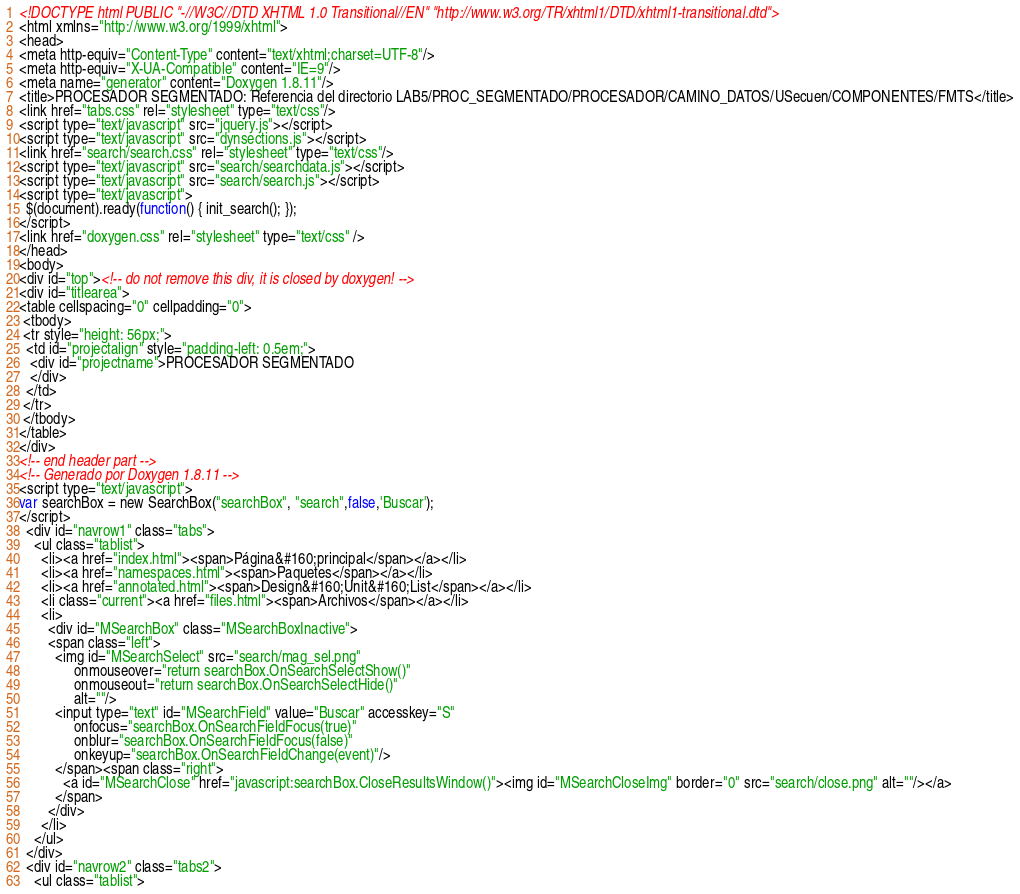<code> <loc_0><loc_0><loc_500><loc_500><_HTML_><!DOCTYPE html PUBLIC "-//W3C//DTD XHTML 1.0 Transitional//EN" "http://www.w3.org/TR/xhtml1/DTD/xhtml1-transitional.dtd">
<html xmlns="http://www.w3.org/1999/xhtml">
<head>
<meta http-equiv="Content-Type" content="text/xhtml;charset=UTF-8"/>
<meta http-equiv="X-UA-Compatible" content="IE=9"/>
<meta name="generator" content="Doxygen 1.8.11"/>
<title>PROCESADOR SEGMENTADO: Referencia del directorio LAB5/PROC_SEGMENTADO/PROCESADOR/CAMINO_DATOS/USecuen/COMPONENTES/FMTS</title>
<link href="tabs.css" rel="stylesheet" type="text/css"/>
<script type="text/javascript" src="jquery.js"></script>
<script type="text/javascript" src="dynsections.js"></script>
<link href="search/search.css" rel="stylesheet" type="text/css"/>
<script type="text/javascript" src="search/searchdata.js"></script>
<script type="text/javascript" src="search/search.js"></script>
<script type="text/javascript">
  $(document).ready(function() { init_search(); });
</script>
<link href="doxygen.css" rel="stylesheet" type="text/css" />
</head>
<body>
<div id="top"><!-- do not remove this div, it is closed by doxygen! -->
<div id="titlearea">
<table cellspacing="0" cellpadding="0">
 <tbody>
 <tr style="height: 56px;">
  <td id="projectalign" style="padding-left: 0.5em;">
   <div id="projectname">PROCESADOR SEGMENTADO
   </div>
  </td>
 </tr>
 </tbody>
</table>
</div>
<!-- end header part -->
<!-- Generado por Doxygen 1.8.11 -->
<script type="text/javascript">
var searchBox = new SearchBox("searchBox", "search",false,'Buscar');
</script>
  <div id="navrow1" class="tabs">
    <ul class="tablist">
      <li><a href="index.html"><span>Página&#160;principal</span></a></li>
      <li><a href="namespaces.html"><span>Paquetes</span></a></li>
      <li><a href="annotated.html"><span>Design&#160;Unit&#160;List</span></a></li>
      <li class="current"><a href="files.html"><span>Archivos</span></a></li>
      <li>
        <div id="MSearchBox" class="MSearchBoxInactive">
        <span class="left">
          <img id="MSearchSelect" src="search/mag_sel.png"
               onmouseover="return searchBox.OnSearchSelectShow()"
               onmouseout="return searchBox.OnSearchSelectHide()"
               alt=""/>
          <input type="text" id="MSearchField" value="Buscar" accesskey="S"
               onfocus="searchBox.OnSearchFieldFocus(true)" 
               onblur="searchBox.OnSearchFieldFocus(false)" 
               onkeyup="searchBox.OnSearchFieldChange(event)"/>
          </span><span class="right">
            <a id="MSearchClose" href="javascript:searchBox.CloseResultsWindow()"><img id="MSearchCloseImg" border="0" src="search/close.png" alt=""/></a>
          </span>
        </div>
      </li>
    </ul>
  </div>
  <div id="navrow2" class="tabs2">
    <ul class="tablist"></code> 